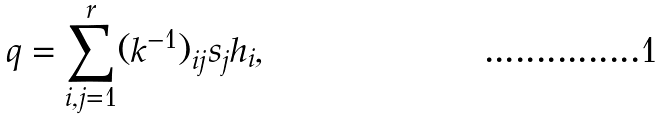<formula> <loc_0><loc_0><loc_500><loc_500>q = \sum _ { i , j = 1 } ^ { r } ( k ^ { - 1 } ) _ { i j } s _ { j } h _ { i } ,</formula> 